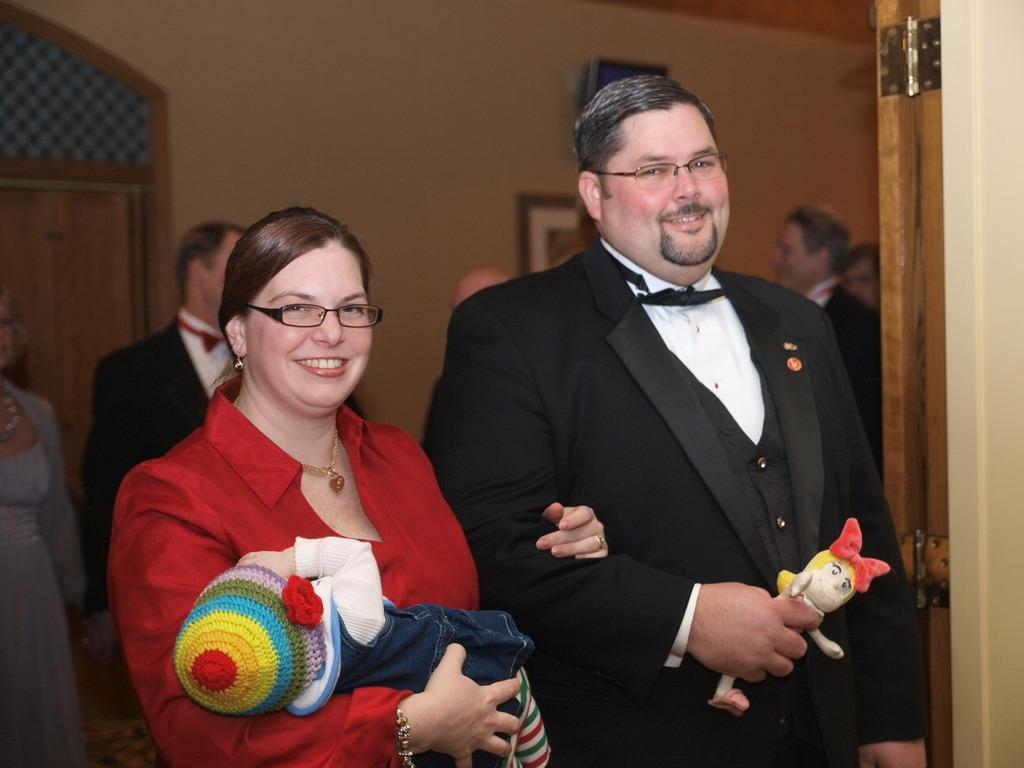How many individuals are present in the image? There are many people in the image. Can you describe the scene in the foreground? There is a couple standing with a baby in the foreground. What can be seen in the background of the image? There is a wall in the background of the image. Where is the door located in the image? The door is on the left side of the image. What color is the crayon being used by the baby in the image? There is no crayon present in the image, and the baby is not using one. How many ducks are visible in the alley behind the wall in the image? There is no alley or ducks present in the image; it only features a wall in the background. 